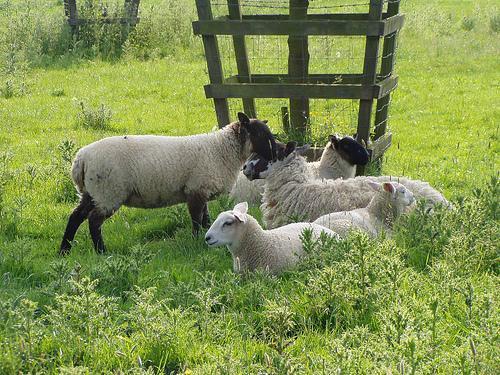How many sheep are in photo?
Give a very brief answer. 4. 